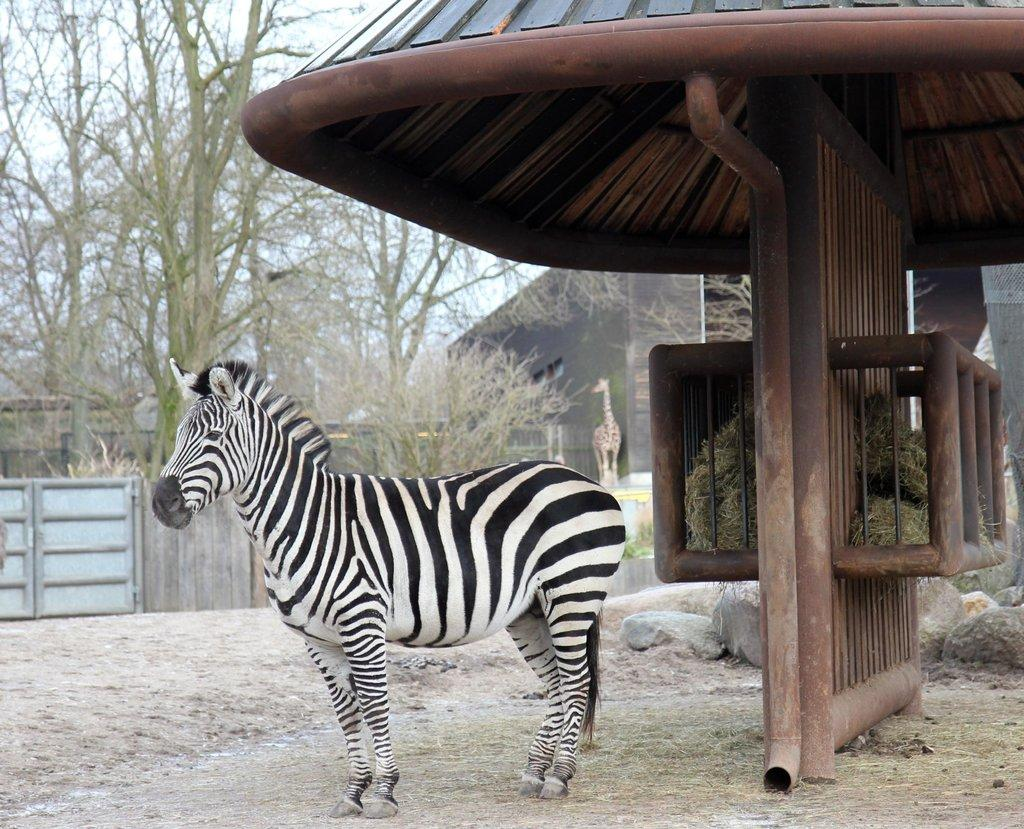What is the main subject in the middle of the image? There is an animal in the middle of the image. What can be seen in the background of the image? There is a group of trees in the background of the image. What type of crown is the animal wearing in the image? There is no crown present in the image; the animal is not wearing any type of crown. 